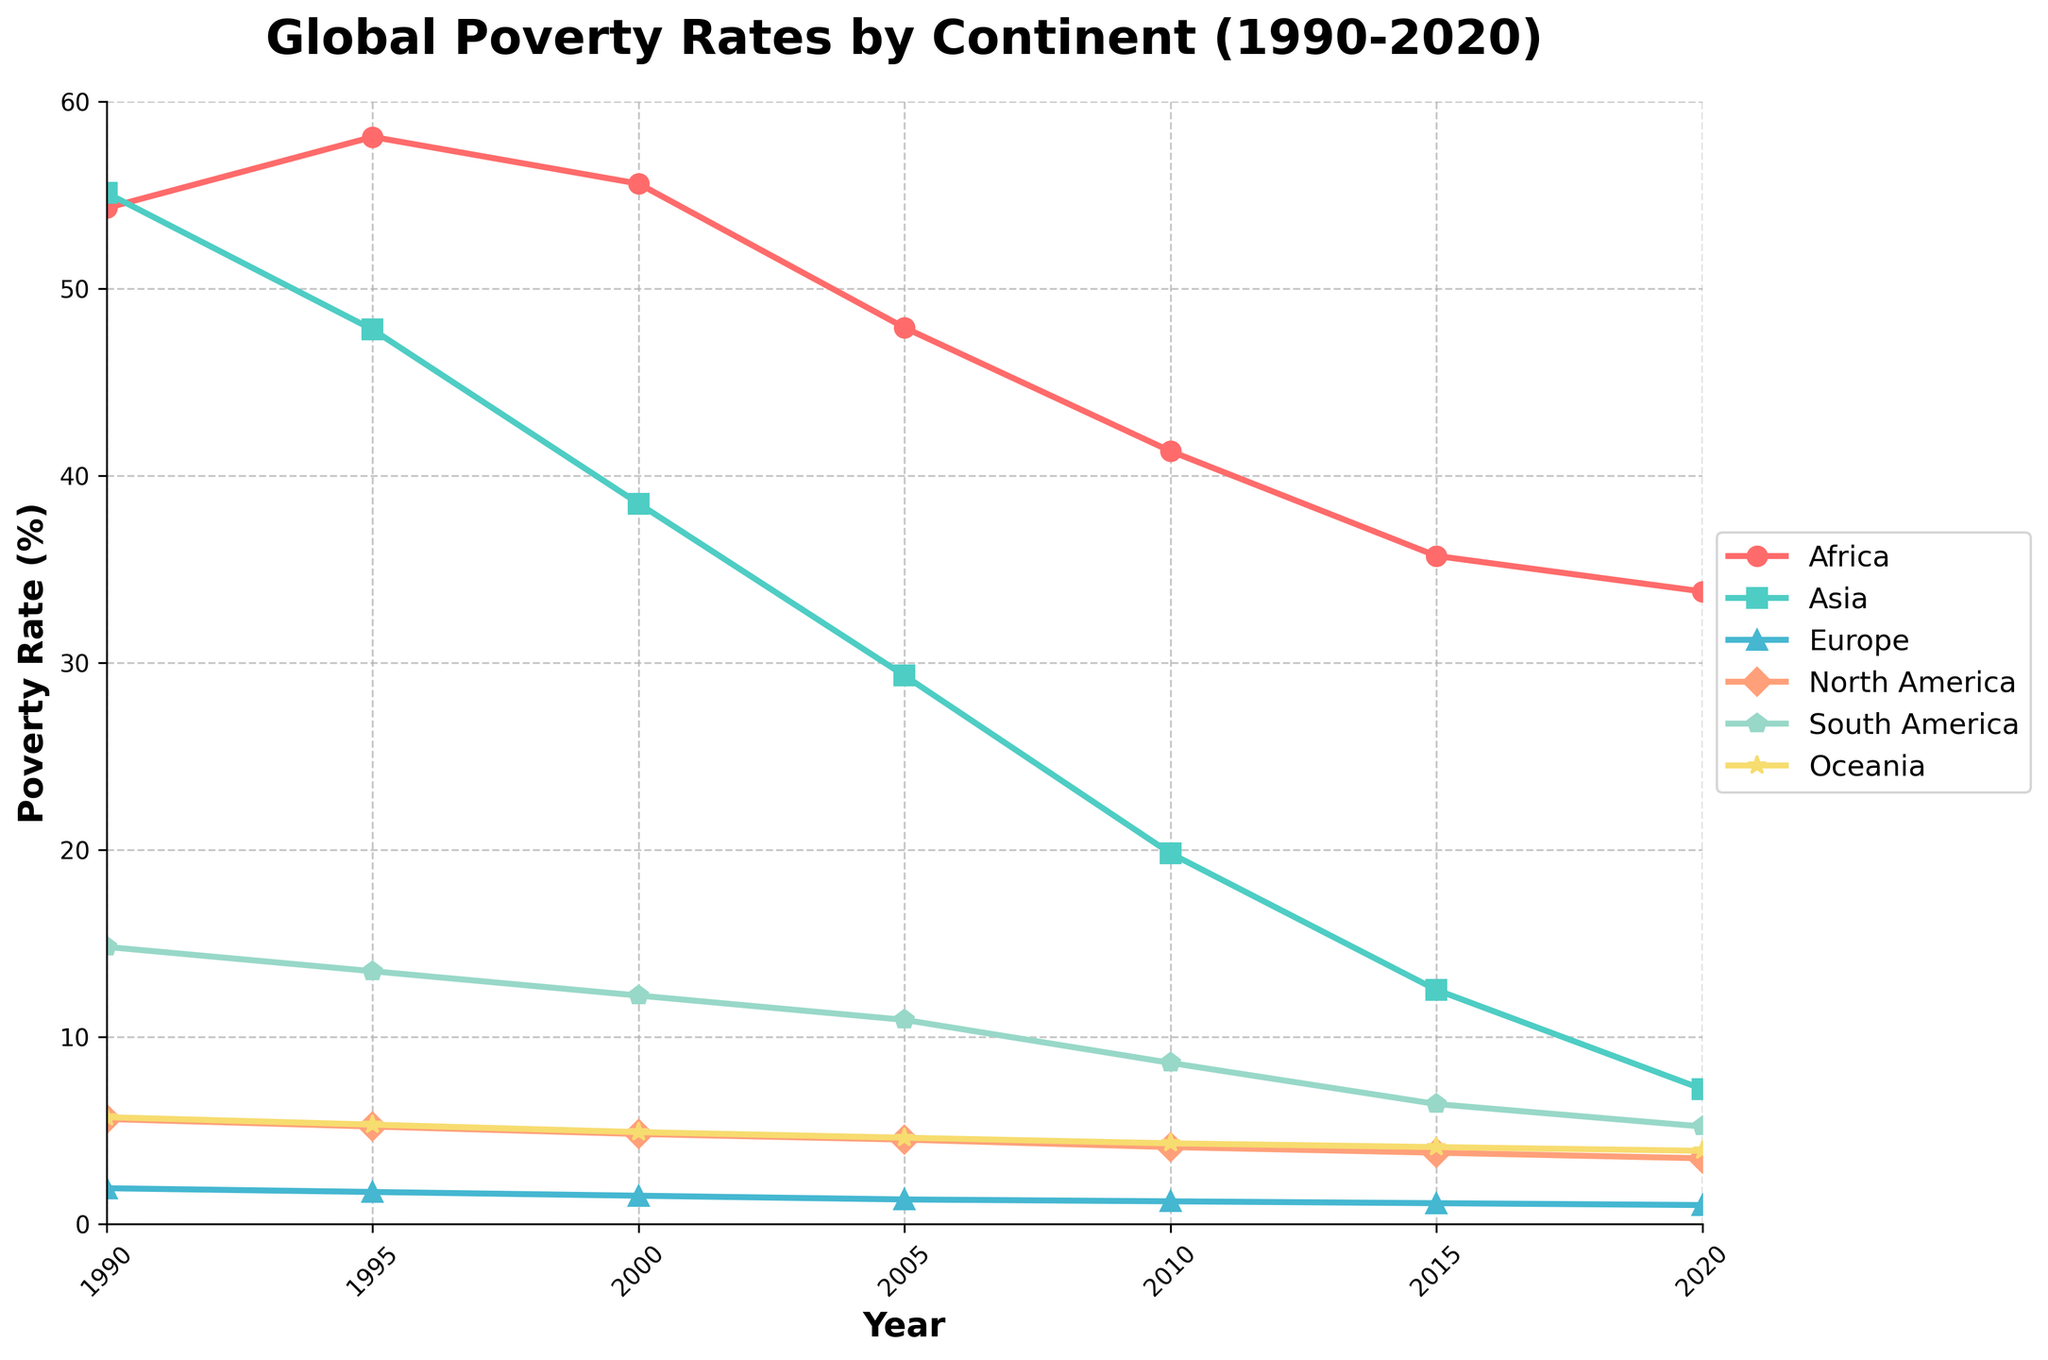What's the trend of poverty rates in Africa from 1990 to 2020? By observing the line representing Africa, we can see that it starts at a poverty rate of 54.3% in 1990, peaks around 1995 at 58.1%, and then generally declines to 33.8% by 2020.
Answer: It declines Which continent had the highest poverty rate in 2000? Looking at the year 2000, the highest point on the y-axis for that year corresponds to Africa with 55.6%.
Answer: Africa Between 1990 and 2020, how much did the poverty rate decrease on average per year in Asia? In 1990, Asia started with a poverty rate of 55.1%. By 2020, the rate was 7.2%. The decrease is 55.1 - 7.2 = 47.9 percentage points over 30 years. So, the average yearly decrease is 47.9 / 30 = 1.5967.
Answer: 1.60% Compare the poverty rates between North America and South America in 2015. Which continent had a higher poverty rate and by how much? In 2015, North America had a poverty rate of 3.8% and South America had a rate of 6.4%. The difference is 6.4% - 3.8% = 2.6%.
Answer: South America by 2.6% Which continent sees the largest decrease in poverty rates from 1990 to 2020? From 1990 to 2020, Asia's poverty rate decreases from 55.1% to 7.2%, a decrease of 55.1 - 7.2 = 47.9%. For other continents, the decreases are: Africa (54.3 to 33.8 = 20.5%), Europe (1.9 to 1.0 = 0.9%), North America (5.6 to 3.5 = 2.1%), South America (14.8 to 5.2 = 9.6%), Oceania (5.7 to 3.9 = 1.8%). Thus, Asia has the largest decrease.
Answer: Asia Compare the trend in poverty rates between Europe and Oceania from 1990 to 2020. In Europe, the poverty rate starts at 1.9% in 1990 and declines to 1.0% by 2020, a small decrease. In Oceania, the rate starts at 5.7% in 1990 and decreases gradually to 3.9% by 2020. Both continents show a downward trend, but Oceania experiences a larger decrease in absolute terms.
Answer: Both decreased, but Oceania more By how much did the poverty rate in South America change from 2010 to 2020? In 2010, the poverty rate in South America was 8.6%, and by 2020, it dropped to 5.2%. The change is 8.6 - 5.2 = 3.4 percentage points.
Answer: 3.4 points What is the average poverty rate in North America over the 30 years shown? Summing the rates for North America from 1990 to 2020: 5.6 + 5.2 + 4.8 + 4.5 + 4.1 + 3.8 + 3.5 = 31.5%. Average is 31.5 / 7 = 4.5%.
Answer: 4.5% What is the visual difference between the poverty rate trends in Africa and Europe? Visually, the line for Africa starts high and shows a general decline from 1995 onwards with more pronounced fluctuations. The line for Europe, however, remains nearly flat at the bottom of the chart around 1%-2%, showing very little change over time.
Answer: Africa shows a declining trend with fluctuations; Europe remains nearly flat 